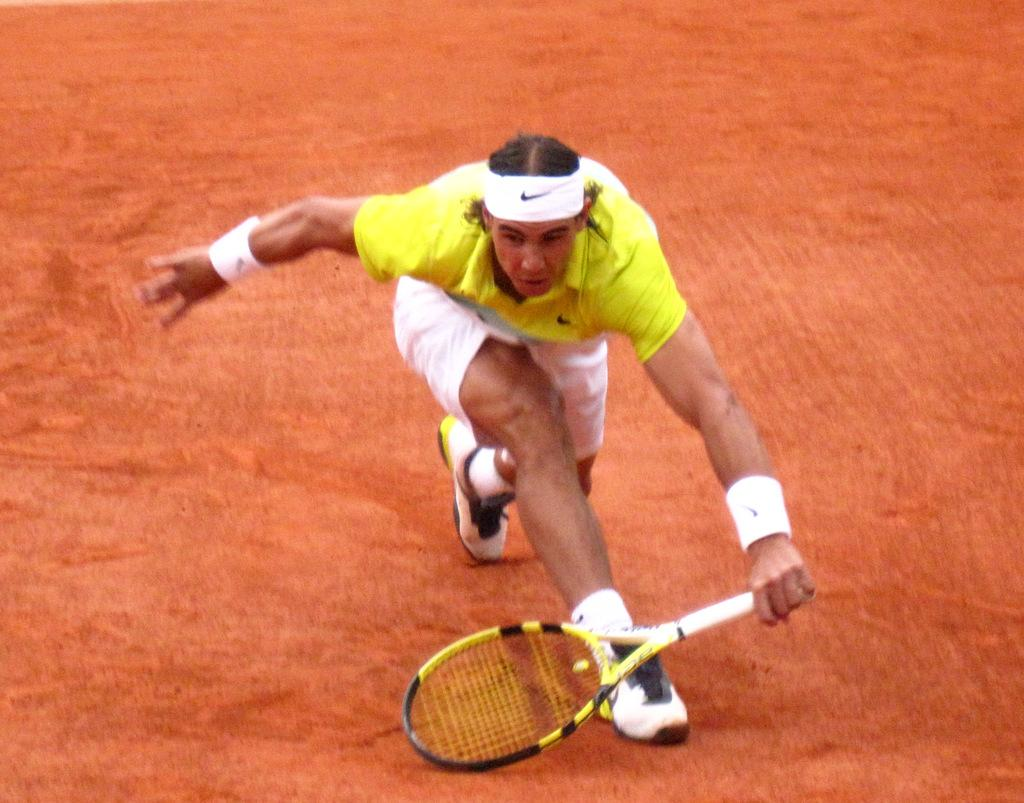Who is present in the image? There is a person in the image. What is the person holding in the image? The person is holding a bat. What is the person doing in the image? The person is in the action of playing. What type of hat is the person wearing in the image? There is no hat present in the image; the person is holding a bat and playing. 